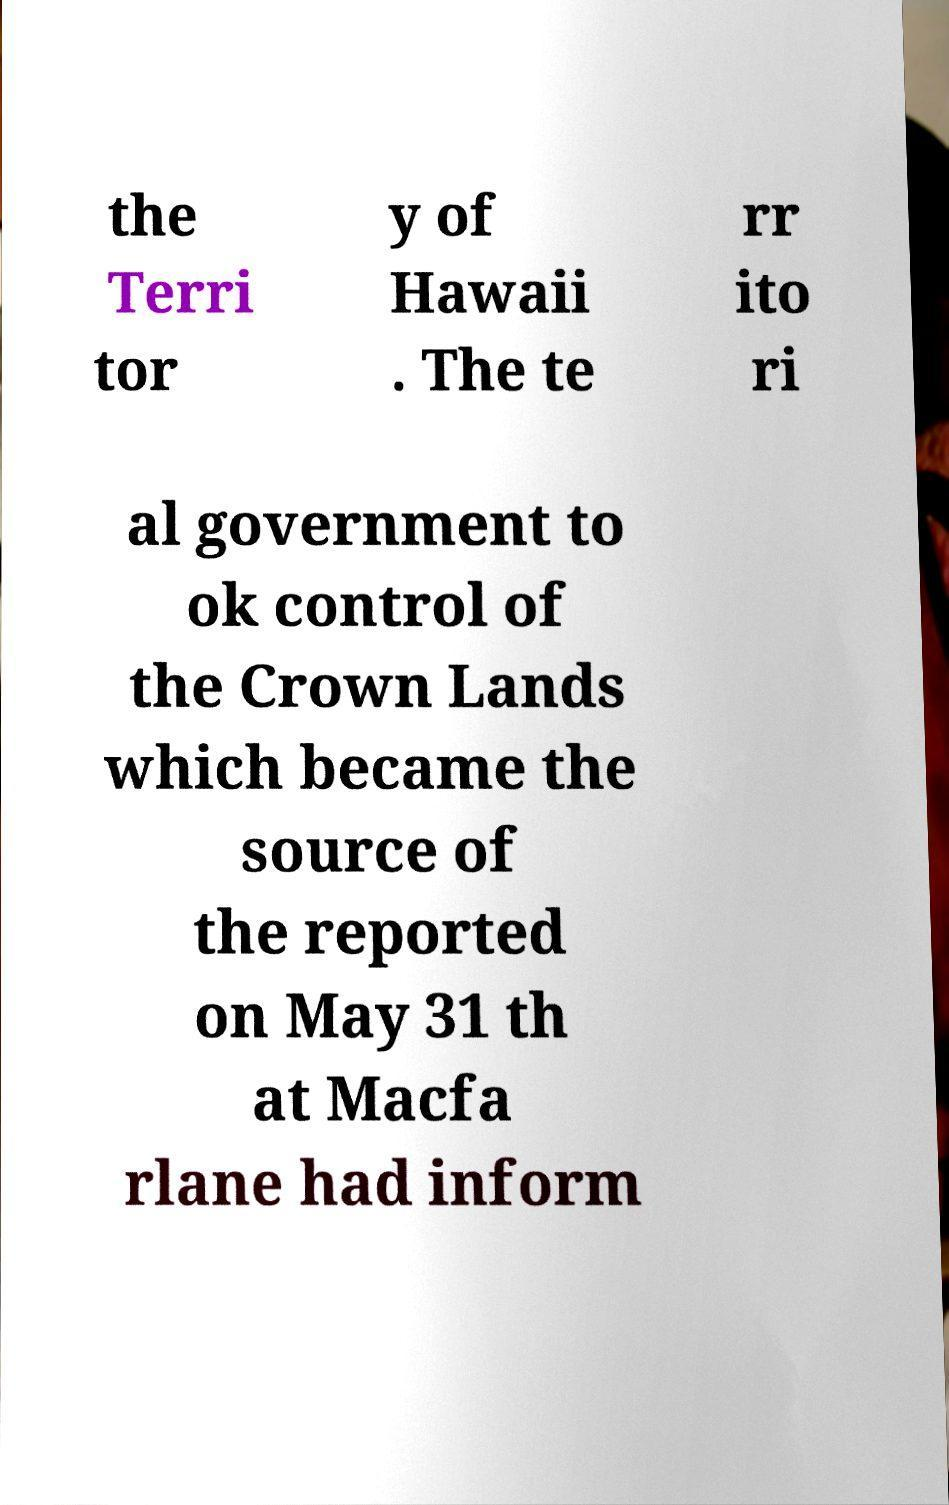There's text embedded in this image that I need extracted. Can you transcribe it verbatim? the Terri tor y of Hawaii . The te rr ito ri al government to ok control of the Crown Lands which became the source of the reported on May 31 th at Macfa rlane had inform 